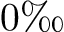<formula> <loc_0><loc_0><loc_500><loc_500>0 \text  perthousand</formula> 